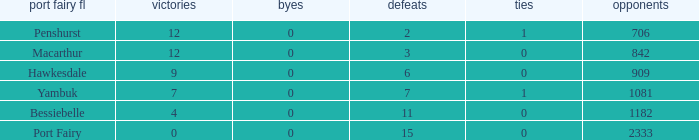Would you be able to parse every entry in this table? {'header': ['port fairy fl', 'victories', 'byes', 'defeats', 'ties', 'opponents'], 'rows': [['Penshurst', '12', '0', '2', '1', '706'], ['Macarthur', '12', '0', '3', '0', '842'], ['Hawkesdale', '9', '0', '6', '0', '909'], ['Yambuk', '7', '0', '7', '1', '1081'], ['Bessiebelle', '4', '0', '11', '0', '1182'], ['Port Fairy', '0', '0', '15', '0', '2333']]} How many byes when the draws are less than 0? 0.0. 